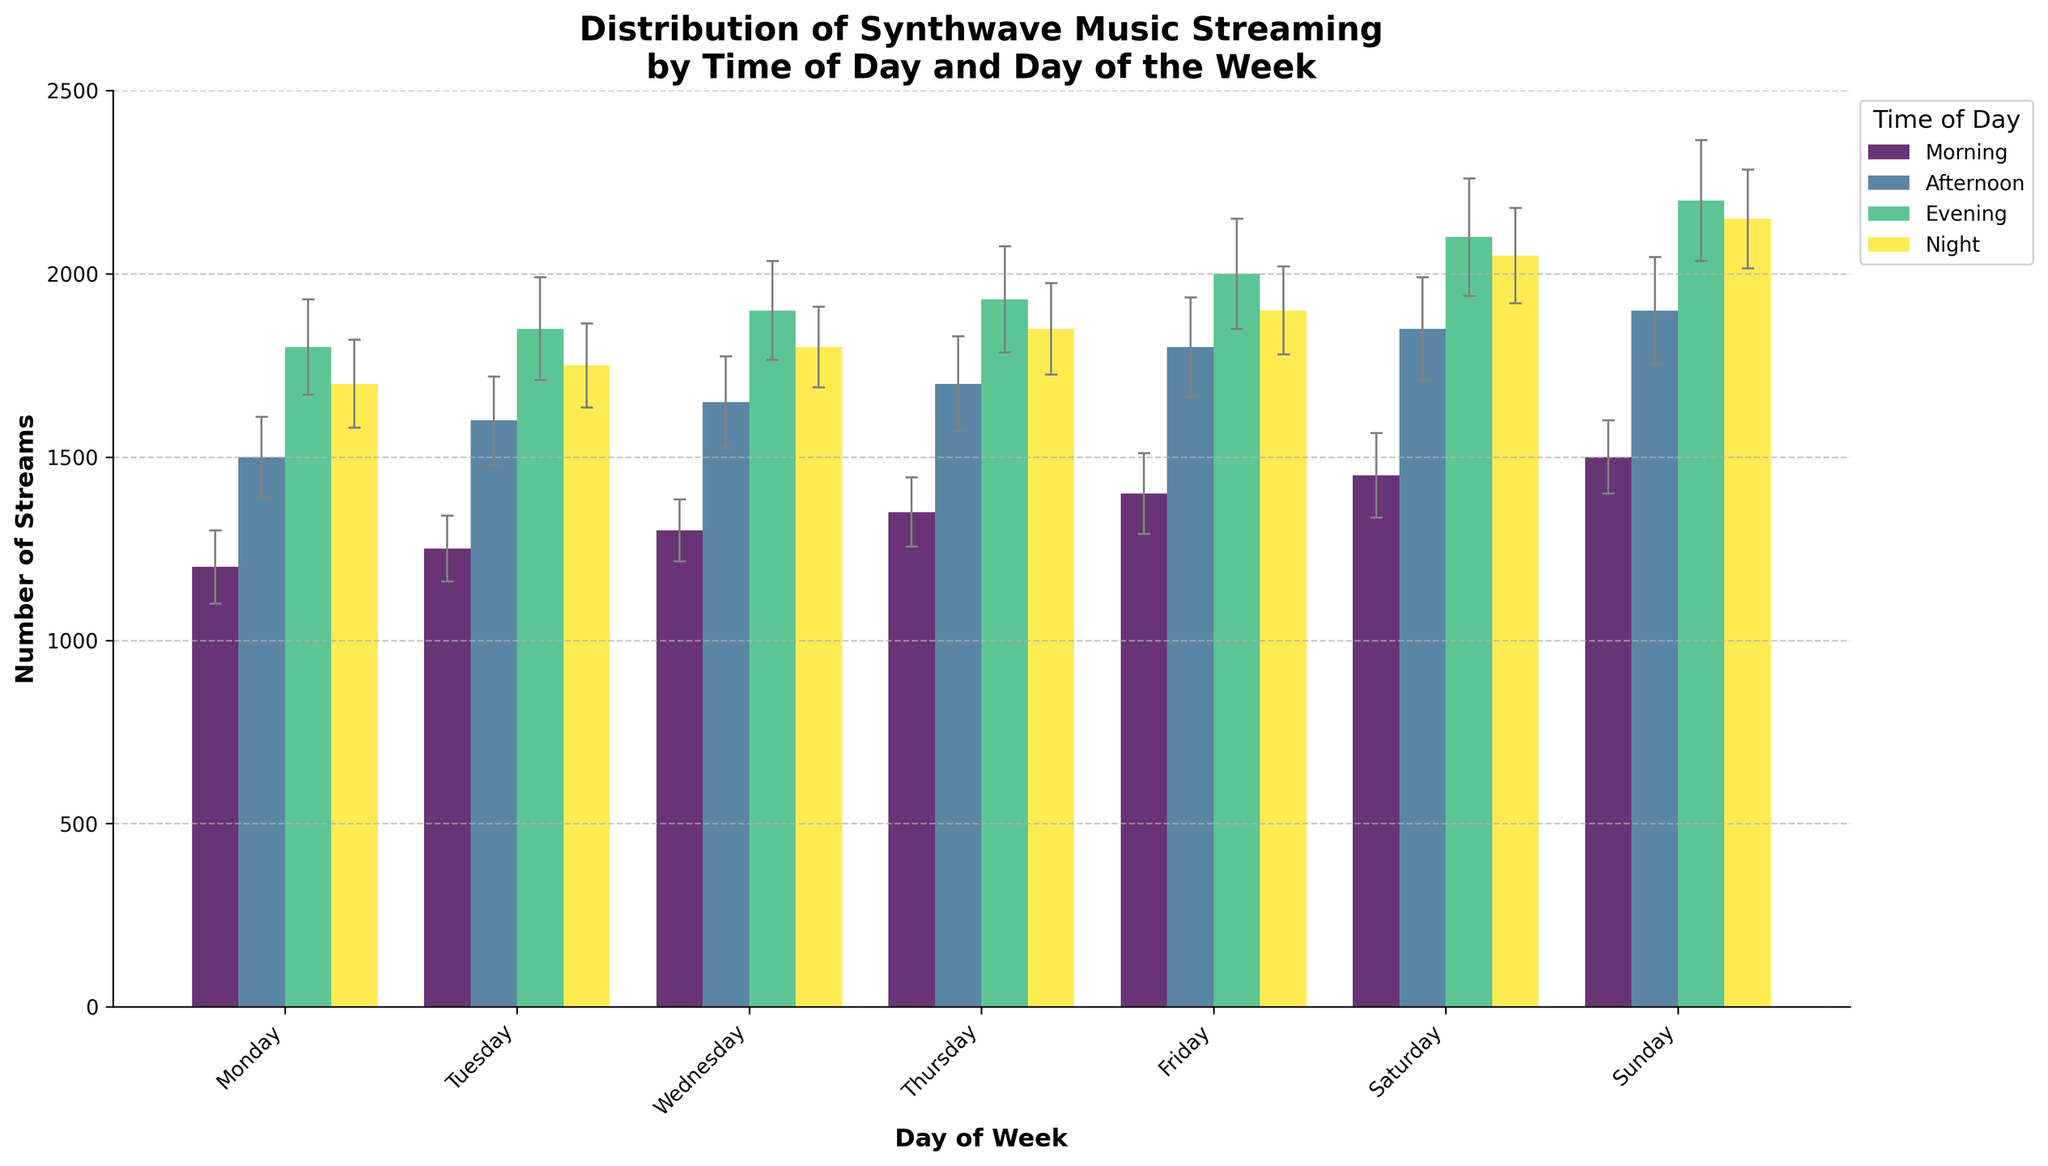What is the title of the figure? The title is located at the top of the figure. It provides a summary of what the figure represents. The title reads: "Distribution of Synthwave Music Streaming by Time of Day and Day of the Week".
Answer: Distribution of Synthwave Music Streaming by Time of Day and Day of the Week On which day and time period do we see the highest mean number of streams? By examining the height of the bars, the highest mean number of streams is observed in the "Evening" time period on "Sunday". The bar is located in the tallest position compared to others.
Answer: Evening, Sunday Which time period generally has the lowest number of streams throughout the week? We compare the mean number of streams for each time period across all days. "Morning" has the lowest mean number of streams for each day.
Answer: Morning On which day do the streams during "Afternoon" have the smallest variation? Variation is indicated by the size of the error bars. Comparing the error bars of the "Afternoon" streams across all days, "Monday" has the smallest error bar.
Answer: Monday What is the approximate difference in mean streams between "Morning" and "Evening" on Wednesday? The mean streams for "Morning" on Wednesday is 1300 and for "Evening" is 1900. The difference is calculated by subtracting 1300 from 1900.
Answer: 600 How do the errors in the "Evening" streams on Saturday compare to those on Sunday? Compare the height of the error bars (gray lines) above the bars for "Saturday" and "Sunday" evenings. The error on Saturday is slightly smaller than that on Sunday.
Answer: Smaller on Saturday Which day shows the most consistency in streaming numbers across all time periods? Consistency can be evaluated by checking which day has the most uniform height of bars and similar error bars. "Monday" streams exhibit relatively uniform bars across all time periods with similar error ranges.
Answer: Monday Are there any days where the "Night" streams outnumber the "Evening" streams? Compare the height of the "Night" bars with the "Evening" bars for each day. No, the "Evening" streams are always higher than the "Night" streams.
Answer: No 